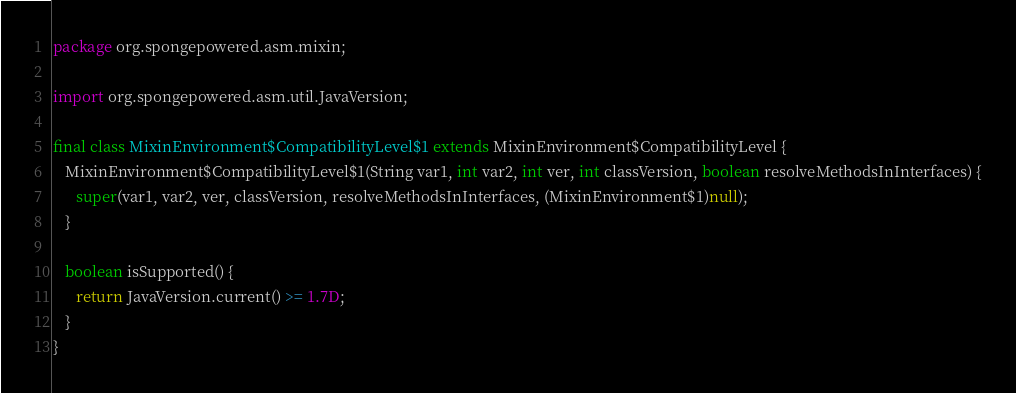Convert code to text. <code><loc_0><loc_0><loc_500><loc_500><_Java_>package org.spongepowered.asm.mixin;

import org.spongepowered.asm.util.JavaVersion;

final class MixinEnvironment$CompatibilityLevel$1 extends MixinEnvironment$CompatibilityLevel {
   MixinEnvironment$CompatibilityLevel$1(String var1, int var2, int ver, int classVersion, boolean resolveMethodsInInterfaces) {
      super(var1, var2, ver, classVersion, resolveMethodsInInterfaces, (MixinEnvironment$1)null);
   }

   boolean isSupported() {
      return JavaVersion.current() >= 1.7D;
   }
}
</code> 